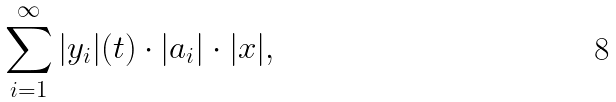Convert formula to latex. <formula><loc_0><loc_0><loc_500><loc_500>\sum _ { i = 1 } ^ { \infty } | y _ { i } | ( t ) \cdot | a _ { i } | \cdot | x | ,</formula> 